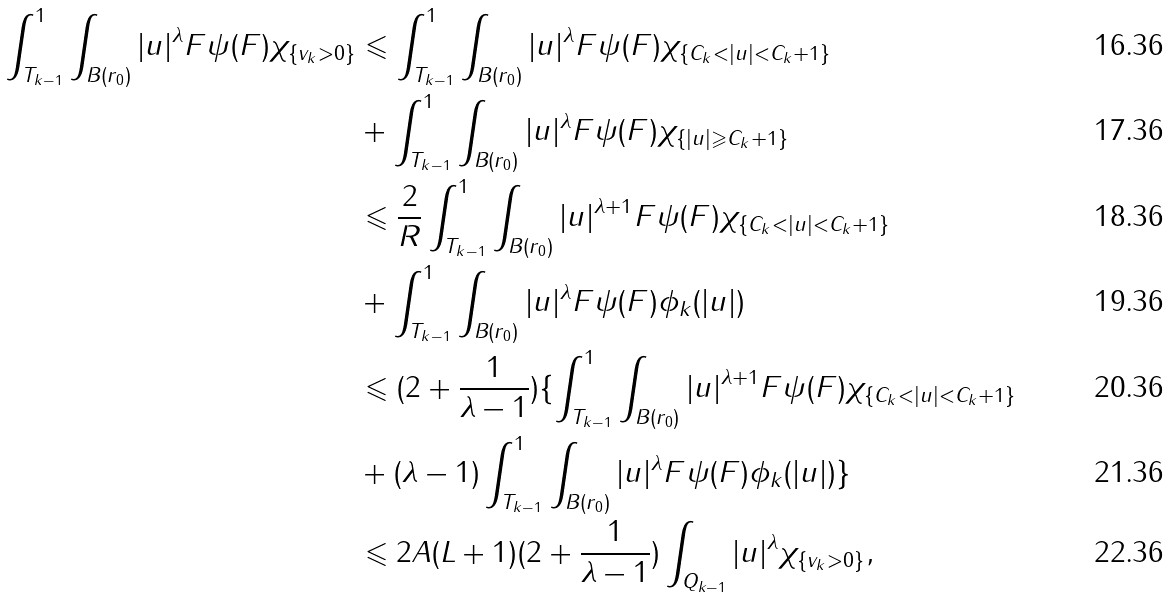Convert formula to latex. <formula><loc_0><loc_0><loc_500><loc_500>\int _ { T _ { k - 1 } } ^ { 1 } \int _ { B ( r _ { 0 } ) } | u | ^ { \lambda } F \psi ( F ) \chi _ { \{ v _ { k } > 0 \} } & \leqslant \int _ { T _ { k - 1 } } ^ { 1 } \int _ { B ( r _ { 0 } ) } | u | ^ { \lambda } F \psi ( F ) \chi _ { \{ C _ { k } < | u | < C _ { k } + 1 \} } \\ & + \int _ { T _ { k - 1 } } ^ { 1 } \int _ { B ( r _ { 0 } ) } | u | ^ { \lambda } F \psi ( F ) \chi _ { \{ | u | \geqslant C _ { k } + 1 \} } \\ & \leqslant \frac { 2 } { R } \int _ { T _ { k - 1 } } ^ { 1 } \int _ { B ( r _ { 0 } ) } | u | ^ { \lambda + 1 } F \psi ( F ) \chi _ { \{ C _ { k } < | u | < C _ { k } + 1 \} } \\ & + \int _ { T _ { k - 1 } } ^ { 1 } \int _ { B ( r _ { 0 } ) } | u | ^ { \lambda } F \psi ( F ) \phi _ { k } ( | u | ) \\ & \leqslant ( 2 + \frac { 1 } { \lambda - 1 } ) \{ \int _ { T _ { k - 1 } } ^ { 1 } \int _ { B ( r _ { 0 } ) } | u | ^ { \lambda + 1 } F \psi ( F ) \chi _ { \{ C _ { k } < | u | < C _ { k } + 1 \} } \\ & + ( \lambda - 1 ) \int _ { T _ { k - 1 } } ^ { 1 } \int _ { B ( r _ { 0 } ) } | u | ^ { \lambda } F \psi ( F ) \phi _ { k } ( | u | ) \} \\ & \leqslant 2 A ( L + 1 ) ( 2 + \frac { 1 } { \lambda - 1 } ) \int _ { Q _ { k - 1 } } | u | ^ { \lambda } \chi _ { \{ v _ { k } > 0 \} } ,</formula> 